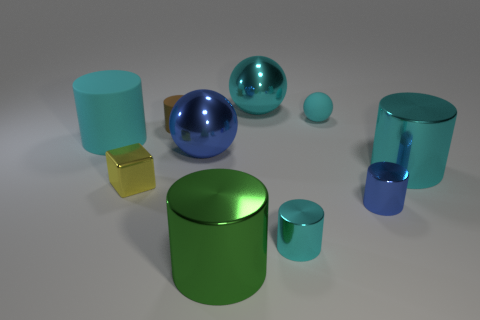Is the number of tiny yellow blocks greater than the number of cyan cylinders?
Give a very brief answer. No. The large metallic thing in front of the large metal cylinder right of the large metal ball that is behind the cyan rubber cylinder is what shape?
Your response must be concise. Cylinder. Is the tiny cyan thing that is to the right of the small cyan cylinder made of the same material as the large cyan cylinder that is to the right of the block?
Offer a terse response. No. What is the shape of the large blue thing that is the same material as the big cyan ball?
Ensure brevity in your answer.  Sphere. Is there any other thing of the same color as the metallic cube?
Give a very brief answer. No. How many tiny gray matte cylinders are there?
Ensure brevity in your answer.  0. The cylinder behind the cylinder that is on the left side of the small yellow metal object is made of what material?
Your answer should be very brief. Rubber. There is a tiny object that is in front of the tiny metal object that is to the right of the rubber object behind the small brown cylinder; what is its color?
Give a very brief answer. Cyan. Does the big matte object have the same color as the small ball?
Give a very brief answer. Yes. How many cyan metallic things are the same size as the brown cylinder?
Provide a short and direct response. 1. 